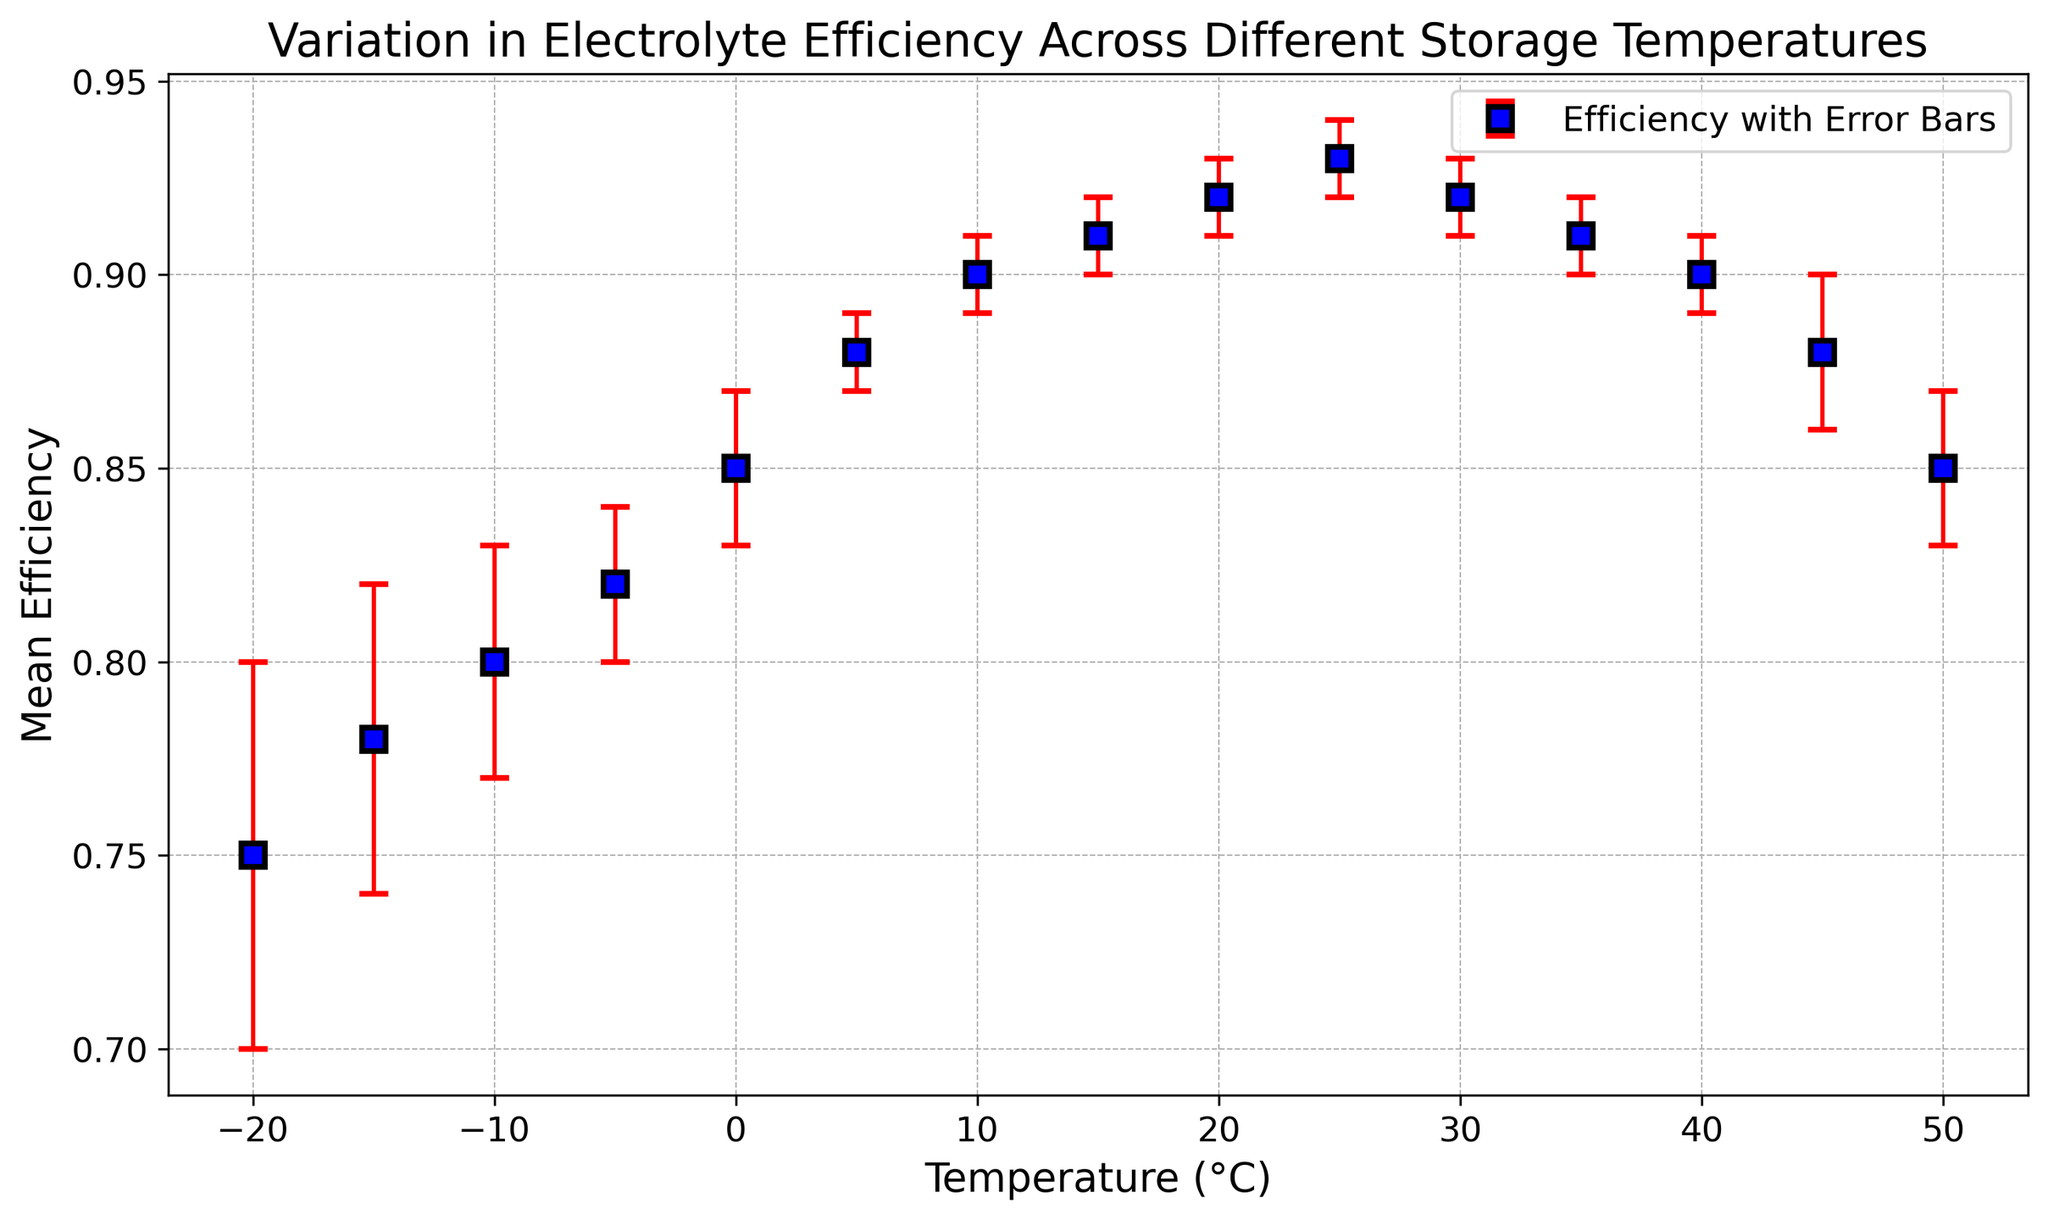What is the mean efficiency at -5°C? Locate the temperature -5°C on the x-axis, then find the corresponding mean efficiency value on the y-axis.
Answer: 0.82 At which temperature is the efficiency the highest? Scan across the efficiency values on the y-axis and find the maximum point. Find the corresponding temperature on the x-axis.
Answer: 25°C What is the difference in mean efficiency between -20°C and 25°C? First, find the mean efficiency at -20°C (0.75) and at 25°C (0.93). Calculate the difference: 0.93 - 0.75.
Answer: 0.18 How does the mean efficiency change as the temperature increases from 0°C to 15°C? Observe the mean efficiency values at 0°C (0.85), 5°C (0.88), 10°C (0.90), and 15°C (0.91). Note the upward trend.
Answer: It increases What is the mean efficiency at 10°C, and what is its associated error? Locate 10°C on the x-axis, then find the mean efficiency on the y-axis (0.90) and the error bar value (0.01).
Answer: 0.90 and 0.01 Which temperature has the largest error bar, and what is its value? Scan the error bars visually and identify the longest. Check the x-axis value.
Answer: -20°C, 0.05 What is the average mean efficiency for temperatures 20°C, 25°C, and 30°C? Find mean efficiencies at 20°C (0.92), 25°C (0.93), and 30°C (0.92). Calculate: (0.92 + 0.93 + 0.92) / 3.
Answer: 0.92 How does the mean efficiency at 50°C compare to the mean efficiency at -10°C? Locate and compare the mean efficiencies at 50°C (0.85) and -10°C (0.80).
Answer: 50°C is higher Which temperature range shows a decline in mean efficiency? Identify the downward trend in mean efficiencies after the peak from 25°C to 50°C.
Answer: 25°C to 50°C Describe the efficiency trend from -20°C to 10°C. Observe the efficiency values: -20°C (0.75), -15°C (0.78), -10°C (0.80), -5°C (0.82), 0°C (0.85), 5°C (0.88), 10°C (0.90). Notice the consistent increase.
Answer: Increasing trend 